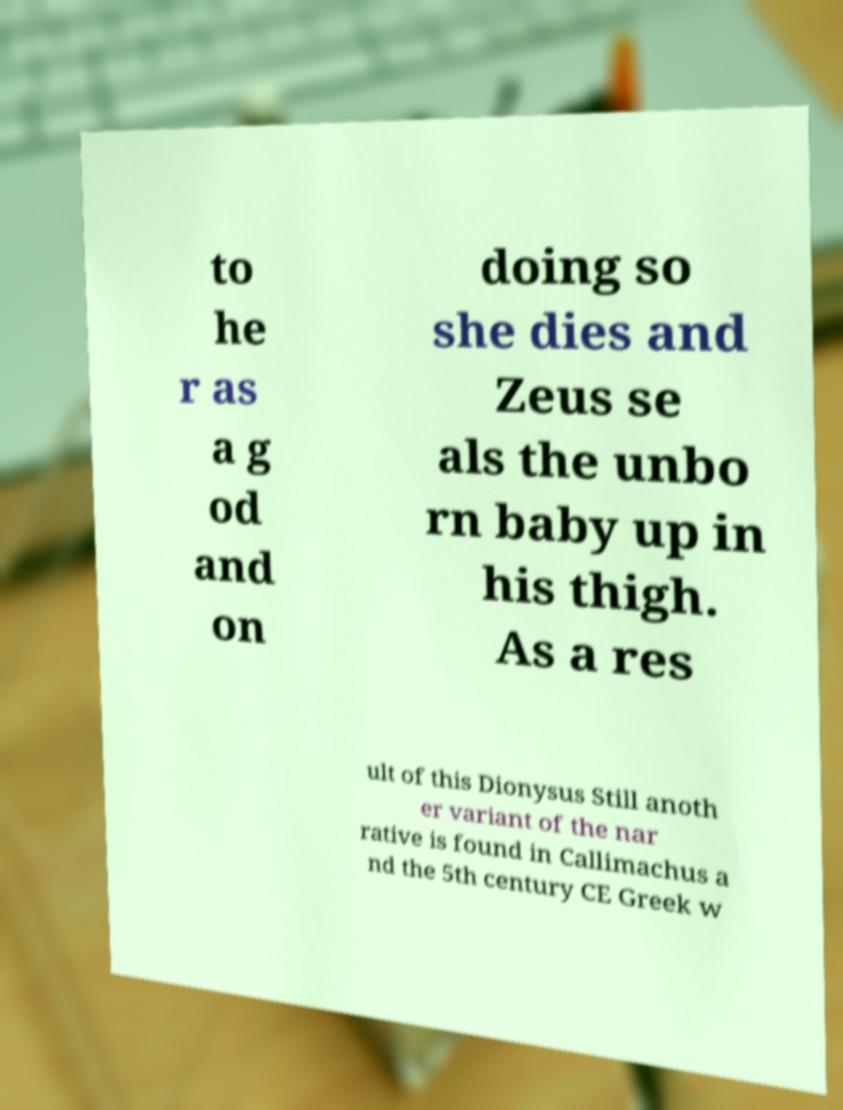Could you extract and type out the text from this image? to he r as a g od and on doing so she dies and Zeus se als the unbo rn baby up in his thigh. As a res ult of this Dionysus Still anoth er variant of the nar rative is found in Callimachus a nd the 5th century CE Greek w 